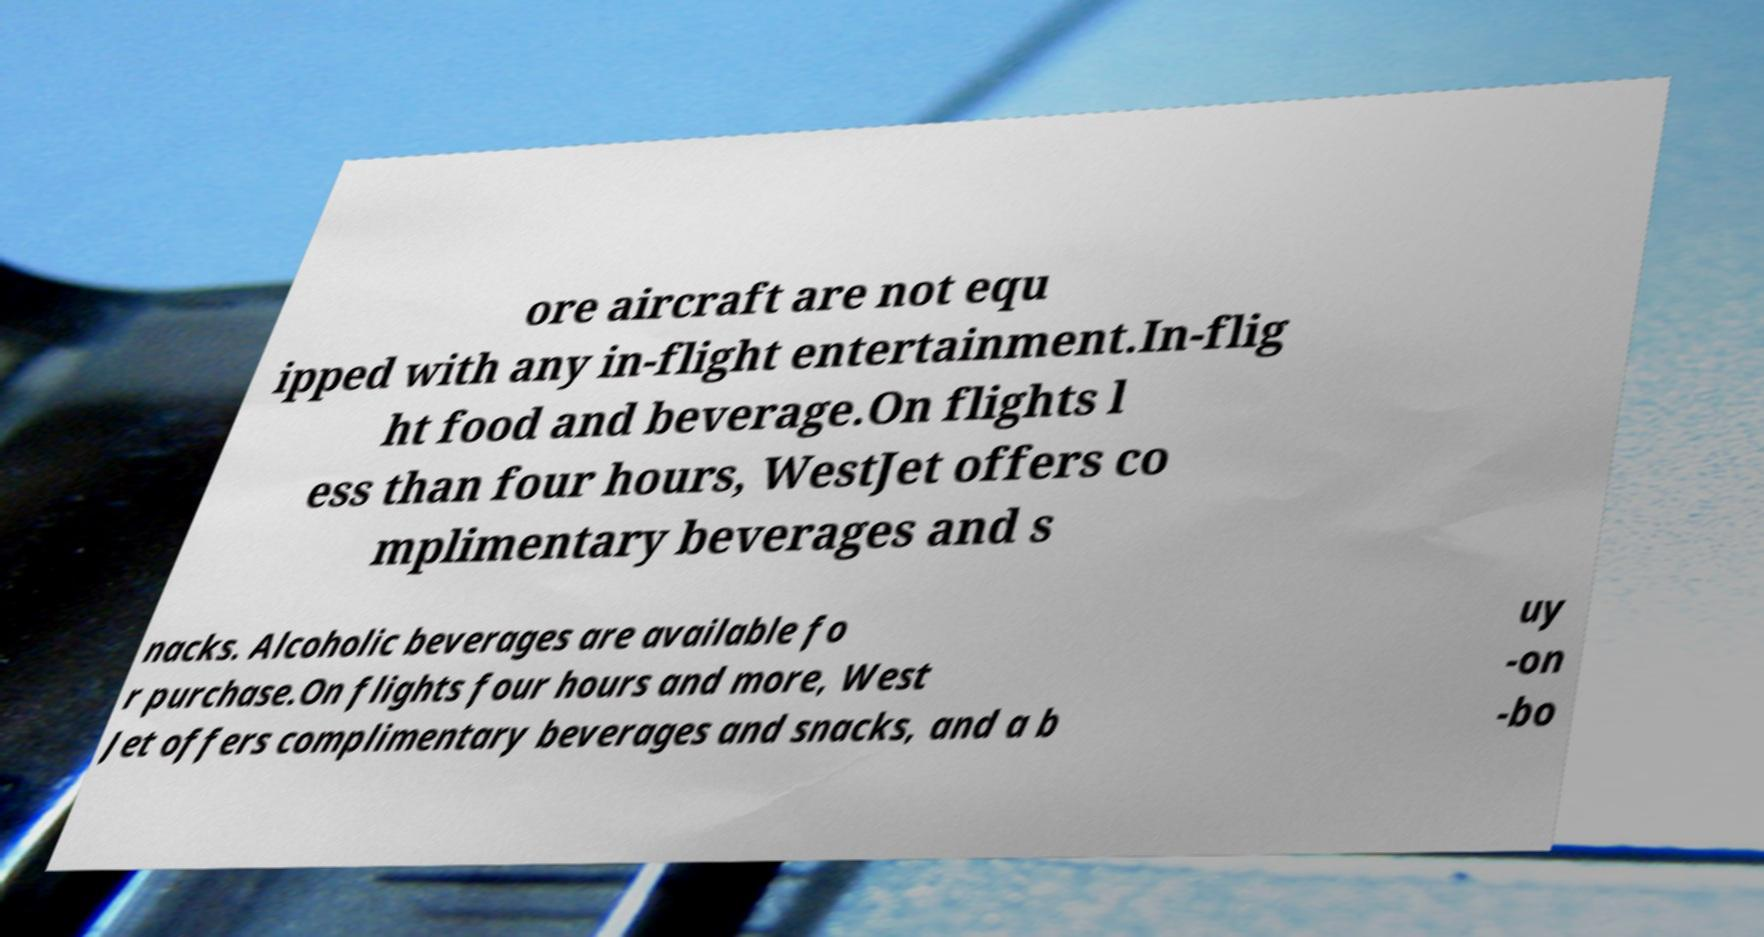Please identify and transcribe the text found in this image. ore aircraft are not equ ipped with any in-flight entertainment.In-flig ht food and beverage.On flights l ess than four hours, WestJet offers co mplimentary beverages and s nacks. Alcoholic beverages are available fo r purchase.On flights four hours and more, West Jet offers complimentary beverages and snacks, and a b uy -on -bo 